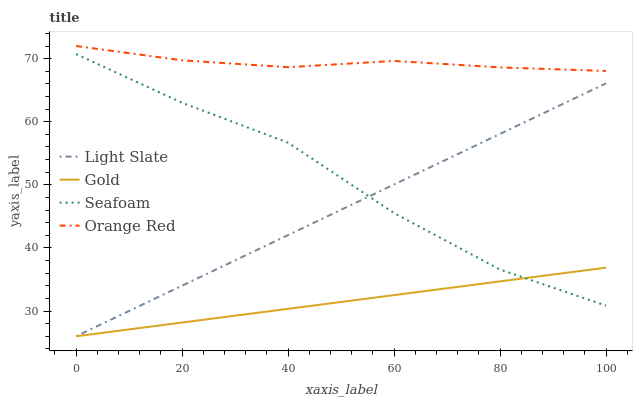Does Gold have the minimum area under the curve?
Answer yes or no. Yes. Does Orange Red have the maximum area under the curve?
Answer yes or no. Yes. Does Seafoam have the minimum area under the curve?
Answer yes or no. No. Does Seafoam have the maximum area under the curve?
Answer yes or no. No. Is Gold the smoothest?
Answer yes or no. Yes. Is Seafoam the roughest?
Answer yes or no. Yes. Is Seafoam the smoothest?
Answer yes or no. No. Is Gold the roughest?
Answer yes or no. No. Does Light Slate have the lowest value?
Answer yes or no. Yes. Does Seafoam have the lowest value?
Answer yes or no. No. Does Orange Red have the highest value?
Answer yes or no. Yes. Does Seafoam have the highest value?
Answer yes or no. No. Is Light Slate less than Orange Red?
Answer yes or no. Yes. Is Orange Red greater than Gold?
Answer yes or no. Yes. Does Gold intersect Seafoam?
Answer yes or no. Yes. Is Gold less than Seafoam?
Answer yes or no. No. Is Gold greater than Seafoam?
Answer yes or no. No. Does Light Slate intersect Orange Red?
Answer yes or no. No. 